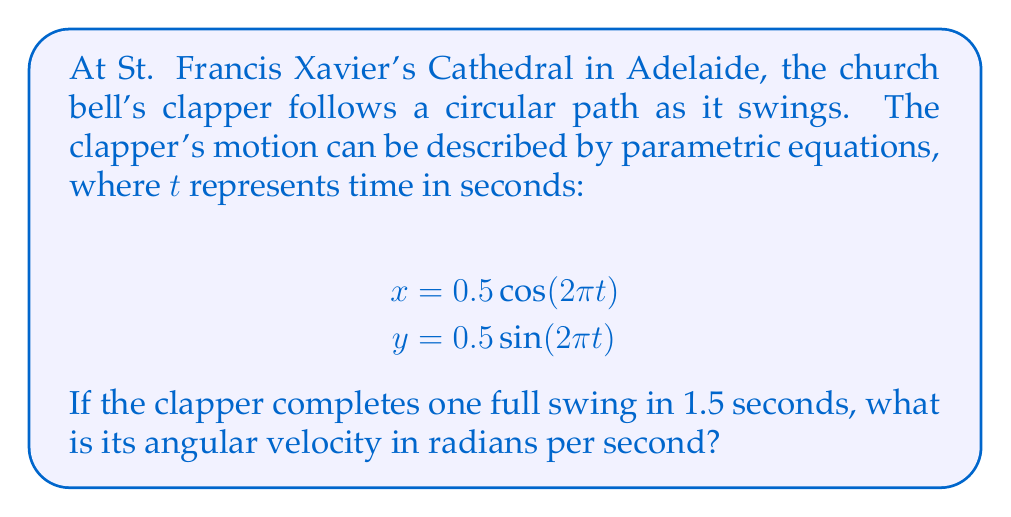Can you answer this question? To solve this problem, we need to understand the relationship between the parametric equations, the period of the motion, and angular velocity.

1) First, let's examine the given parametric equations:
   $$x = 0.5 \cos(2\pi t)$$
   $$y = 0.5 \sin(2\pi t)$$

   These equations describe a circular path with a radius of 0.5 units.

2) The general form of parametric equations for circular motion is:
   $$x = r \cos(\omega t)$$
   $$y = r \sin(\omega t)$$
   where $r$ is the radius and $\omega$ is the angular velocity in radians per second.

3) Comparing our given equations to the general form, we can see that:
   $$2\pi = \omega$$

4) However, we need to consider the period of the motion. We're told that the clapper completes one full swing in 1.5 seconds. This means that the period $T = 1.5$ seconds.

5) The relationship between angular velocity $\omega$ and period $T$ is:
   $$\omega = \frac{2\pi}{T}$$

6) Substituting our known period:
   $$\omega = \frac{2\pi}{1.5} = \frac{4\pi}{3} \approx 4.19 \text{ radians per second}$$

Therefore, the angular velocity of the clapper is $\frac{4\pi}{3}$ radians per second.
Answer: $\frac{4\pi}{3}$ radians per second 